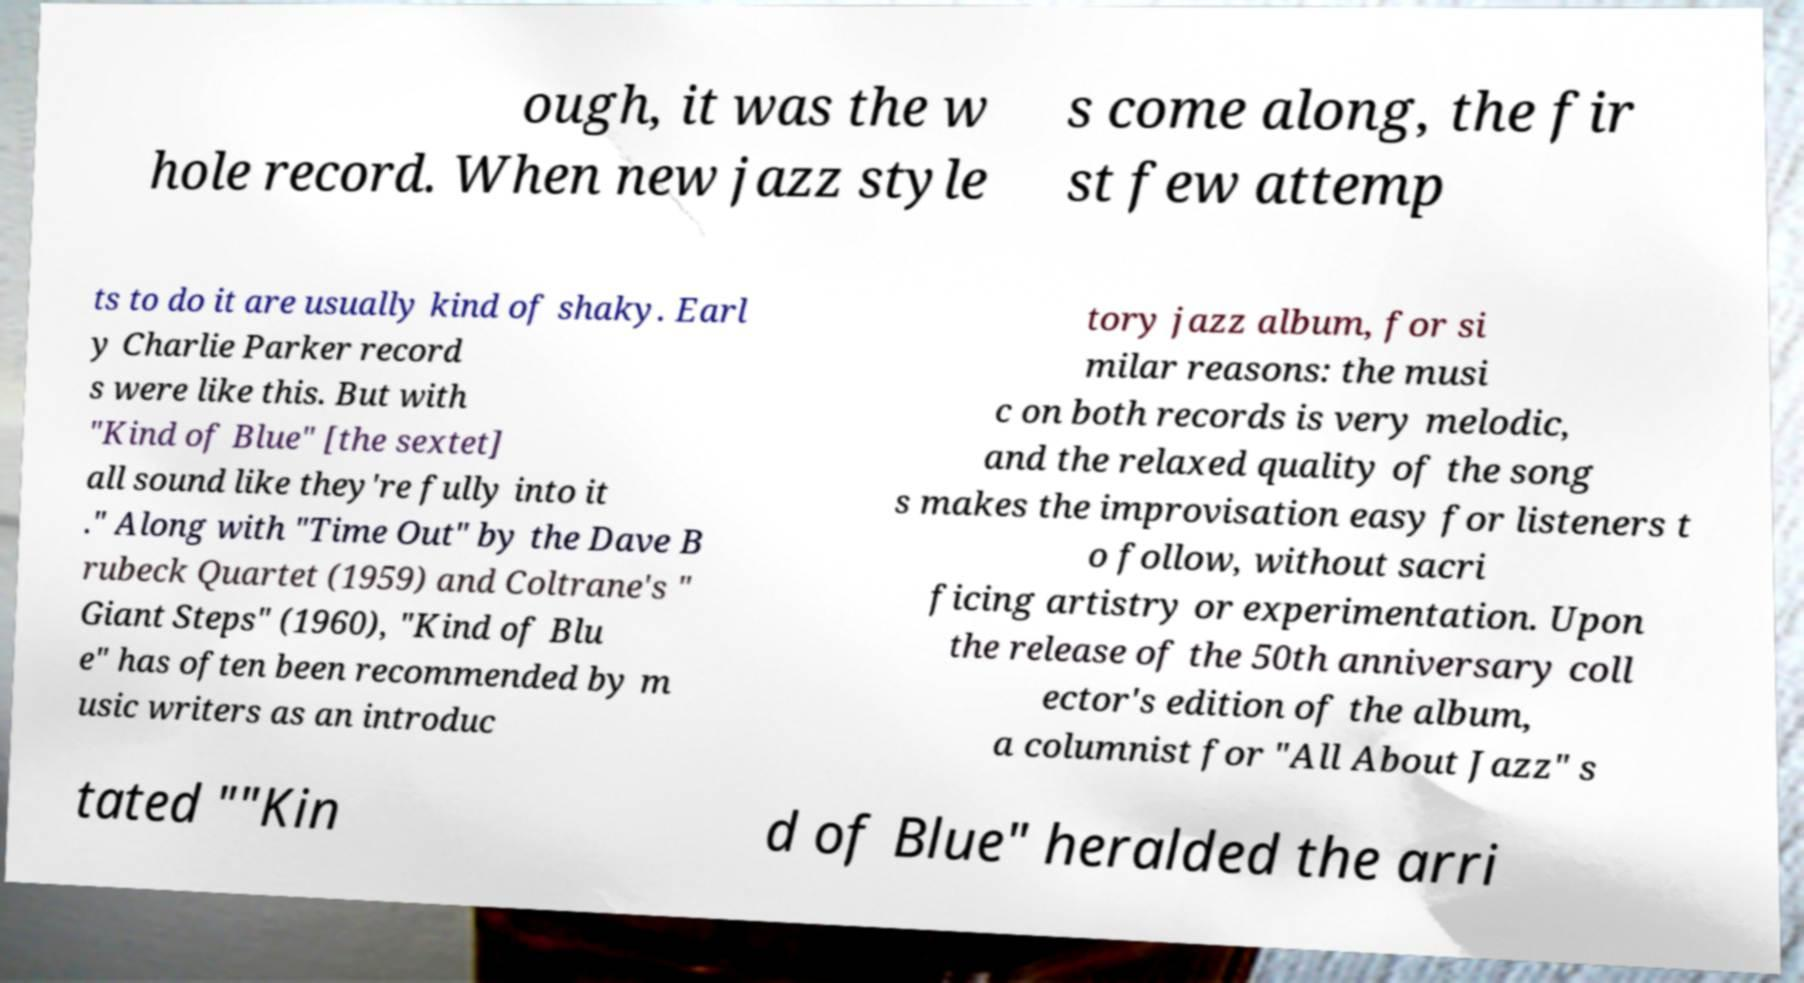Could you extract and type out the text from this image? ough, it was the w hole record. When new jazz style s come along, the fir st few attemp ts to do it are usually kind of shaky. Earl y Charlie Parker record s were like this. But with "Kind of Blue" [the sextet] all sound like they're fully into it ." Along with "Time Out" by the Dave B rubeck Quartet (1959) and Coltrane's " Giant Steps" (1960), "Kind of Blu e" has often been recommended by m usic writers as an introduc tory jazz album, for si milar reasons: the musi c on both records is very melodic, and the relaxed quality of the song s makes the improvisation easy for listeners t o follow, without sacri ficing artistry or experimentation. Upon the release of the 50th anniversary coll ector's edition of the album, a columnist for "All About Jazz" s tated ""Kin d of Blue" heralded the arri 